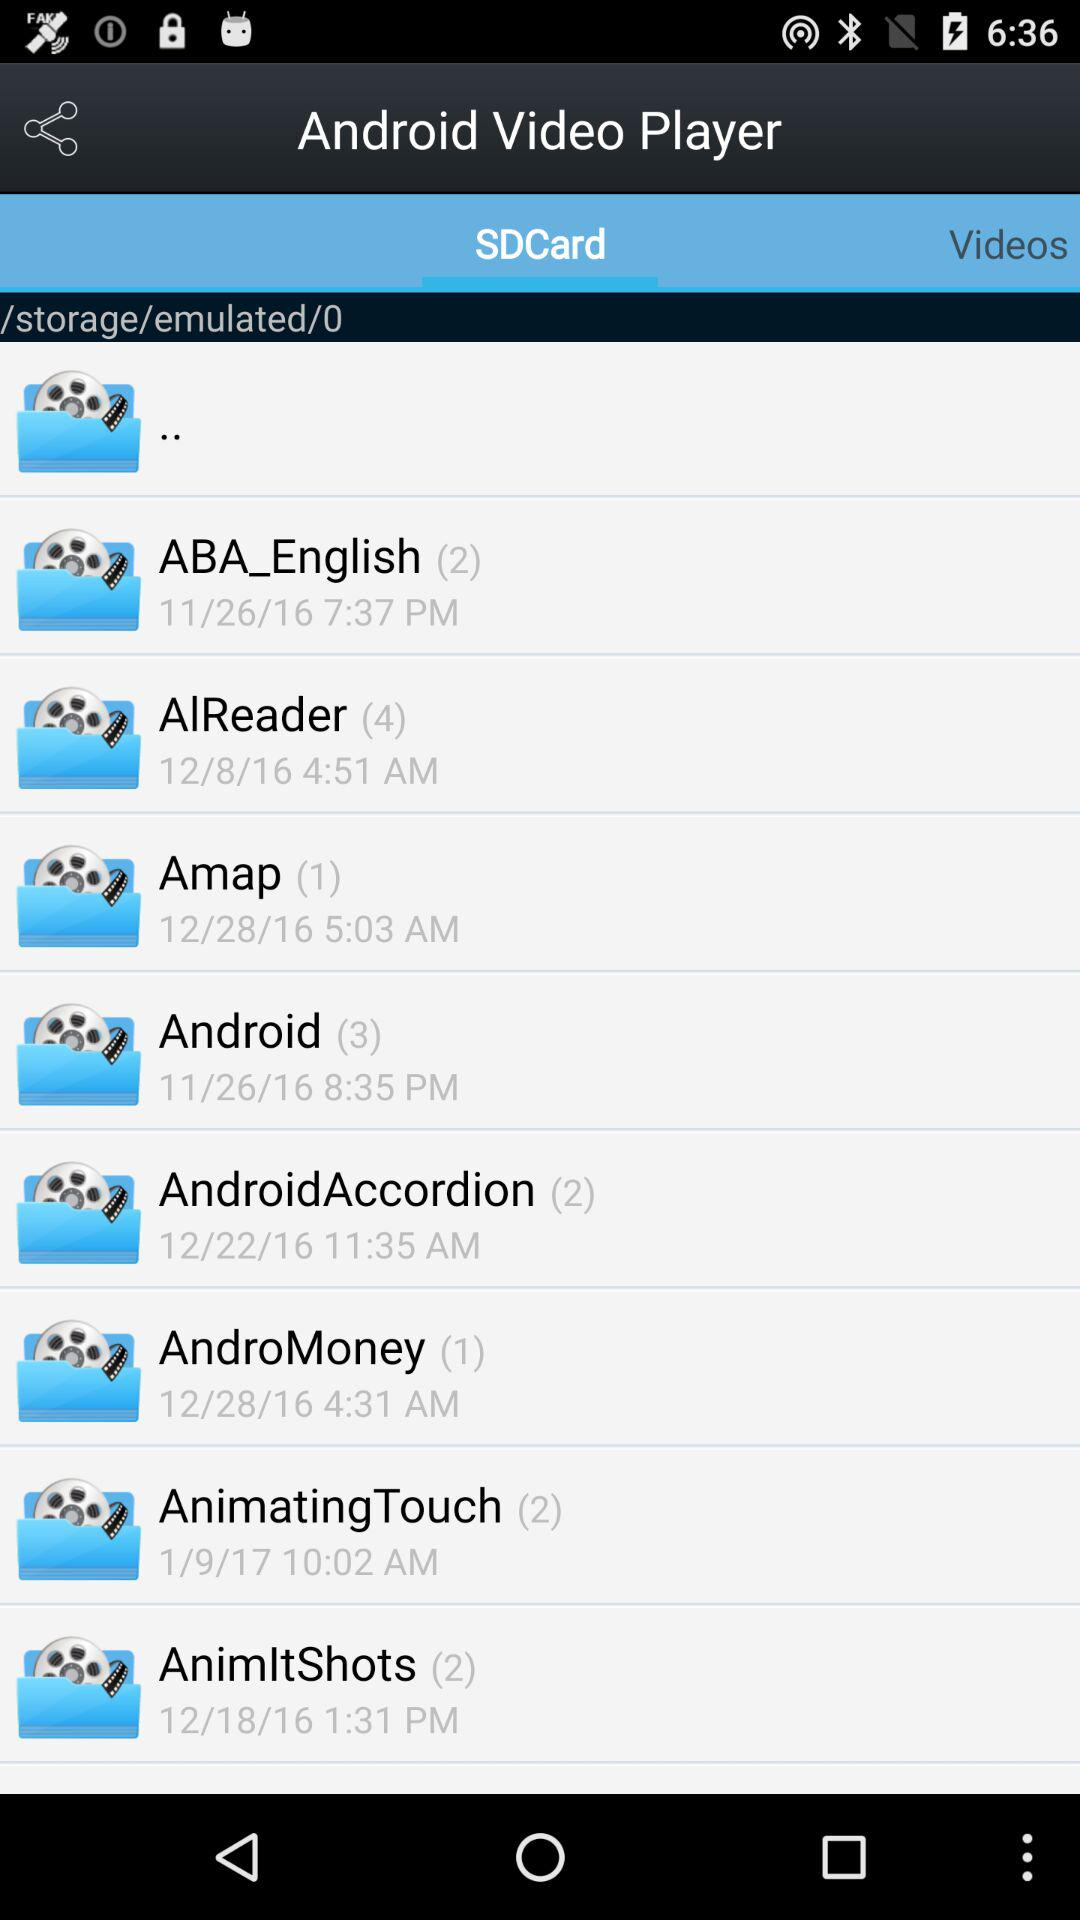Which tab is selected? The selected tab is "SDCard". 